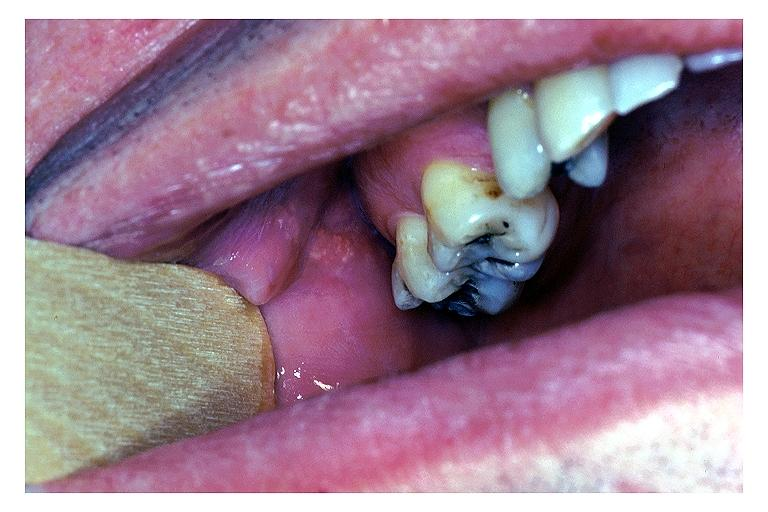does this image show fordyce granules?
Answer the question using a single word or phrase. Yes 